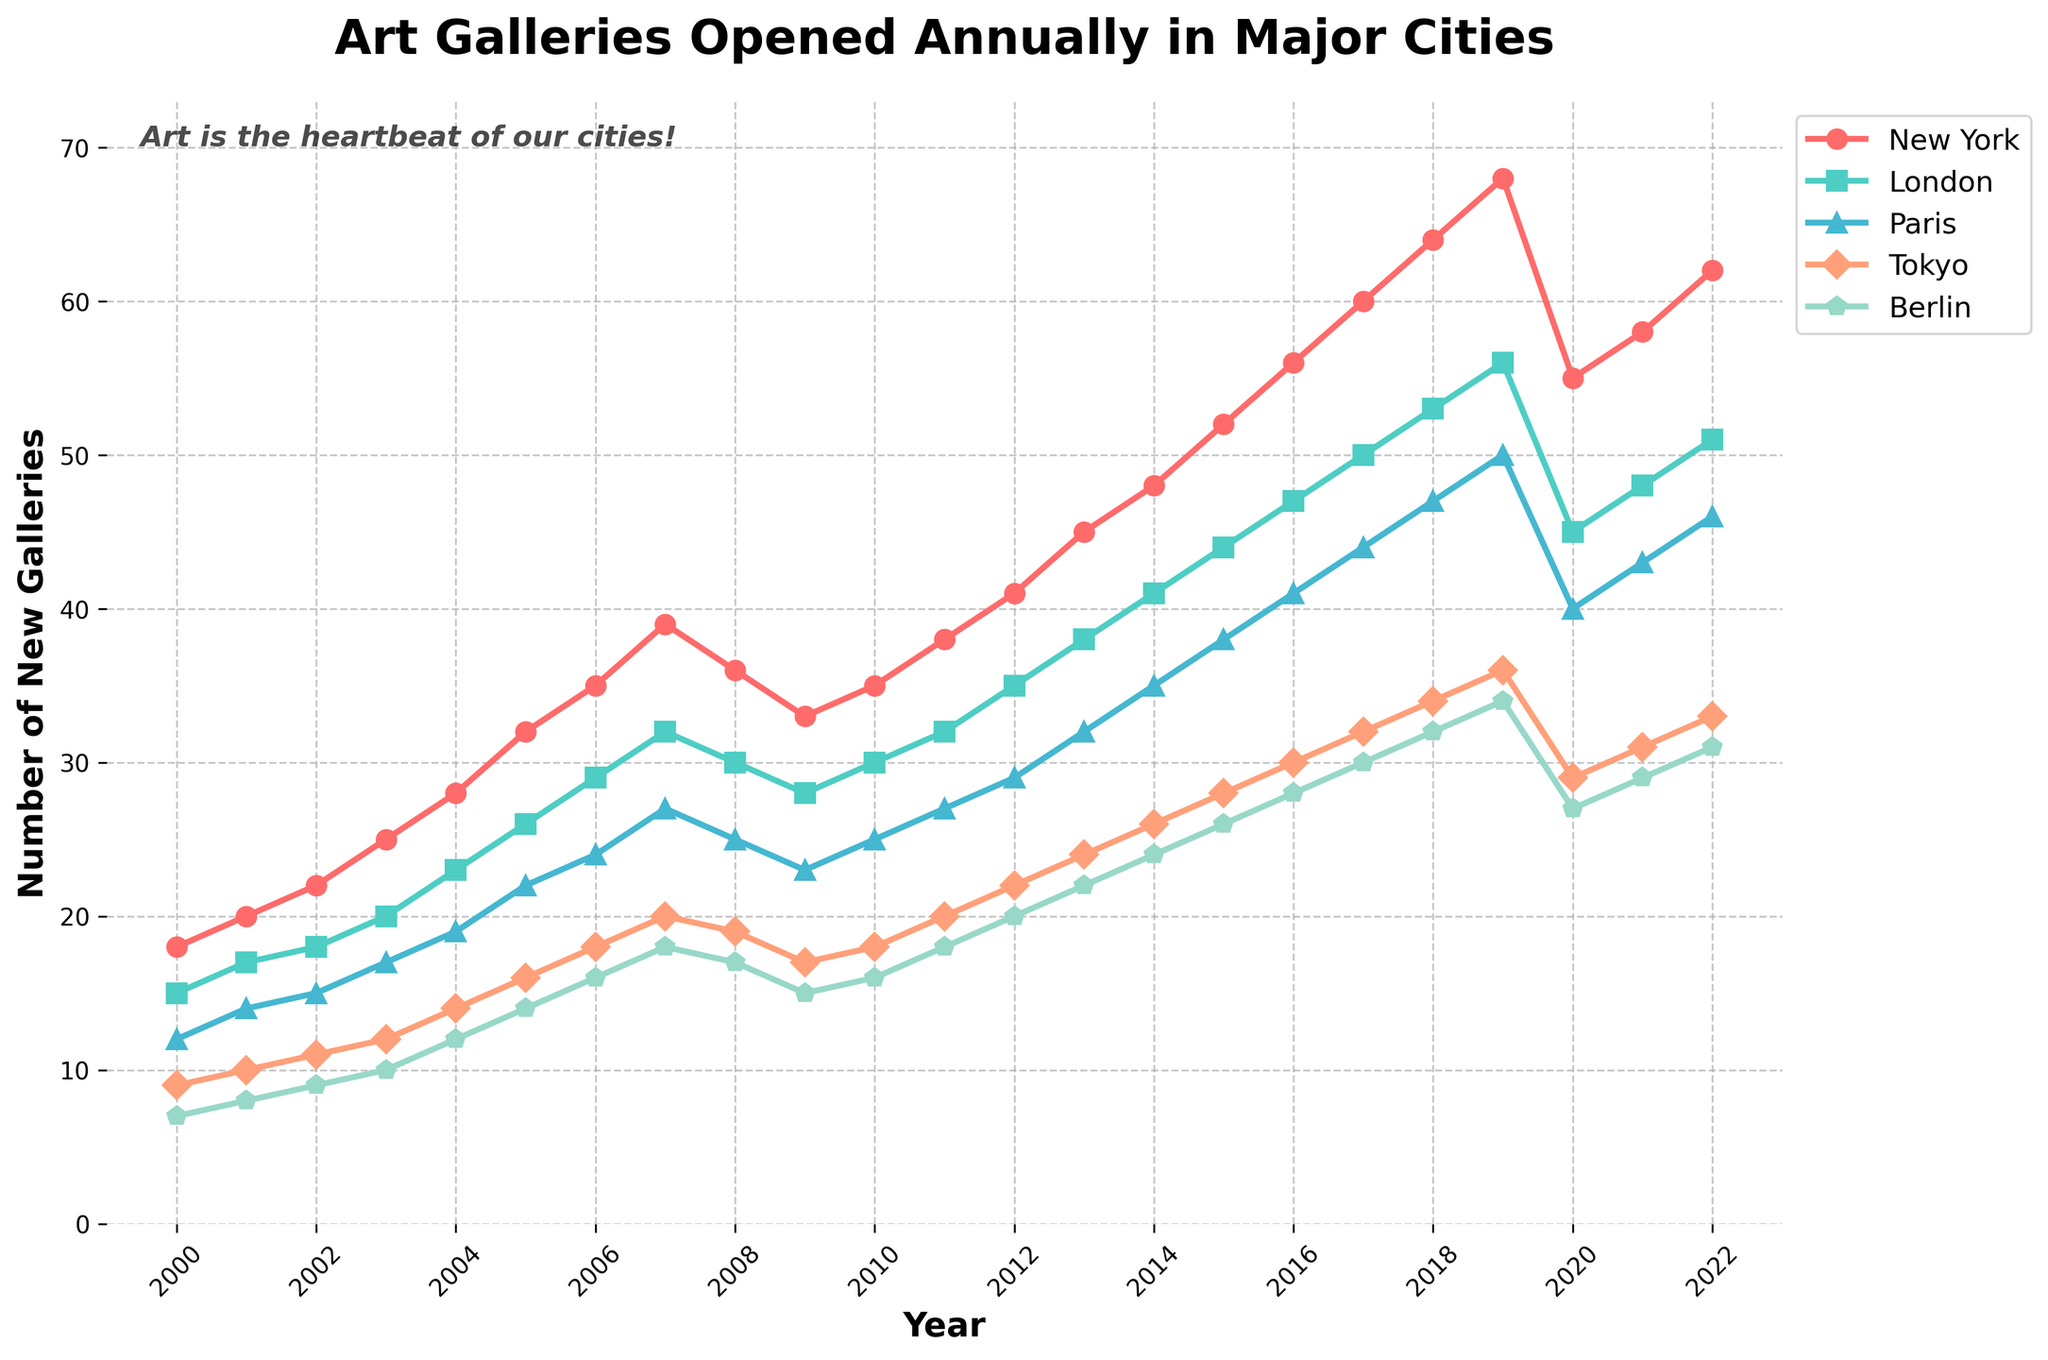Which city had the highest number of art galleries opened in 2019? To find the city with the highest number of art galleries opened in 2019, locate the year 2019 on the x-axis and compare the y-values of all cities. New York has the highest y-value.
Answer: New York Between 2010 and 2015, which city saw the largest increase in the number of new art galleries? Identify the y-values for each city in 2010 and 2015, then calculate the differences. New York: 52-35 = 17, London: 44-30 = 14, Paris: 38-25 = 13, Tokyo: 28-18 = 10, Berlin: 26-16 = 10. New York had the largest increase.
Answer: New York What was the average number of new art galleries opened in Berlin between 2000 and 2009? Sum the number of new galleries in Berlin from 2000 to 2009: 7 + 8 + 9 + 10 + 12 + 14 + 16 + 18 + 17 + 15 = 126. Then divide by 10: 126/10 = 12.6.
Answer: 12.6 In which year did the number of art galleries opened in Tokyo first surpass 30? Identify the y-values for Tokyo along the timeline and find when it exceeds 30. The number first surpasses 30 in 2018 where Tokyo has 34.
Answer: 2018 How many new galleries were opened in Paris in 2005 compared to 2010? Check the y-values for Paris in 2005 and 2010. In 2005, it is 22, and in 2010, it is 25. The difference is 25 - 22 = 3.
Answer: 3 Which city experienced a decrease in the number of new art galleries opened between 2019 and 2020? Observe the y-values from 2019 to 2020 for each city. New York decreases from 68 to 55, which is the noticeable drop.
Answer: New York What color represents the data line for London? Look at the color-coded lines and identify the color used for London. The color used for London is green.
Answer: Green How many new art galleries did Tokyo open in 2006? Find the y-value for Tokyo for the year 2006. It shows 18 new galleries.
Answer: 18 Which two cities have the closest number of new galleries opened in 2021? Compare the y-values for all cities in 2021. Tokyo (31) and Berlin (29) have the closest values.
Answer: Tokyo and Berlin Comparing 2020 and 2022, which city shows the most significant recovery in the number of new art galleries opened? Find the difference for each city between 2020 and 2022. New York: 62-55 = 7, London: 51-45 = 6, Paris: 46-40 = 6, Tokyo: 33-29 = 4, Berlin: 31-27 = 4. New York has the highest increase.
Answer: New York 